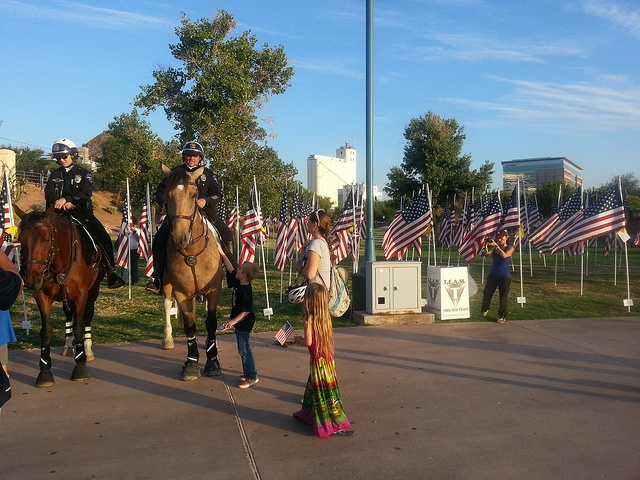Describe the objects in this image and their specific colors. I can see horse in lightblue, black, maroon, and gray tones, horse in lightblue, black, brown, and maroon tones, people in lightblue, black, maroon, brown, and olive tones, people in lightblue, black, gray, tan, and ivory tones, and people in lightblue, black, gray, and maroon tones in this image. 